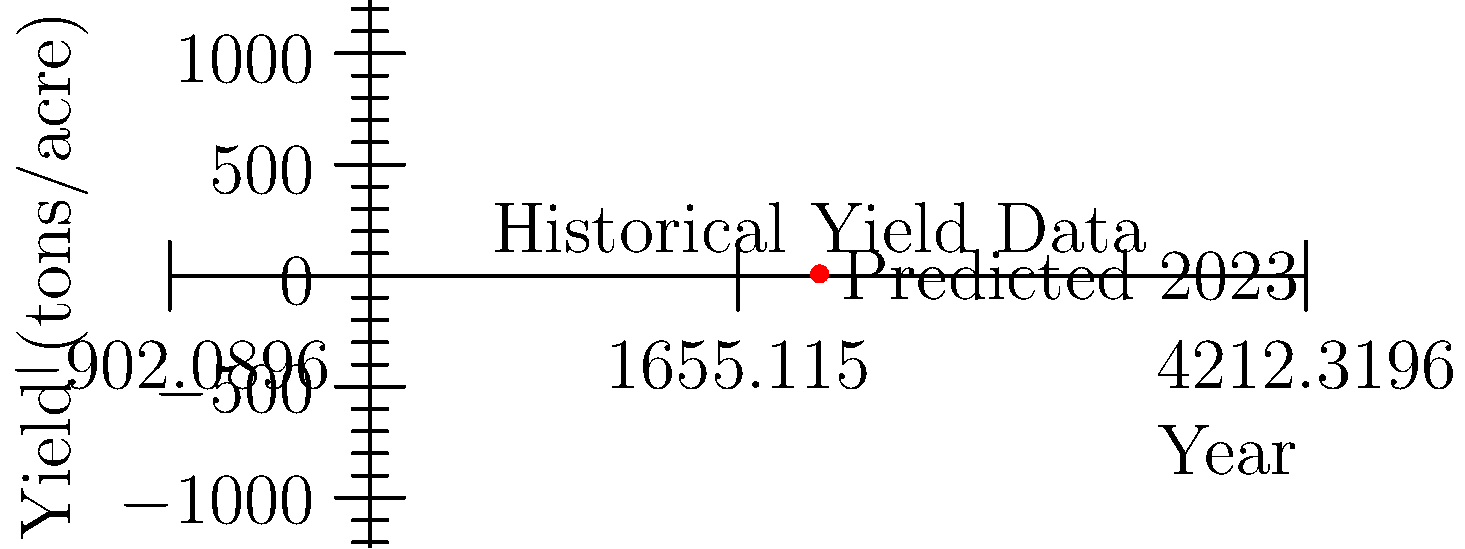Based on the historical grape yield data shown in the graph and considering that this year's vine growth patterns indicate a 3% increase from last year's yield, estimate the grape yield for 2023 in tons per acre. To estimate the grape yield for 2023, we'll follow these steps:

1. Identify last year's (2022) yield from the graph: 7.4 tons/acre

2. Calculate the expected increase:
   $3\% \text{ of } 7.4 = 0.03 \times 7.4 = 0.222 \text{ tons/acre}$

3. Add the increase to last year's yield:
   $7.4 + 0.222 = 7.622 \text{ tons/acre}$

4. Round to one decimal place for practical purposes:
   $7.622 \approx 7.6 \text{ tons/acre}$

This estimation aligns with the red dot on the graph, which represents the predicted yield for 2023.
Answer: 7.6 tons/acre 